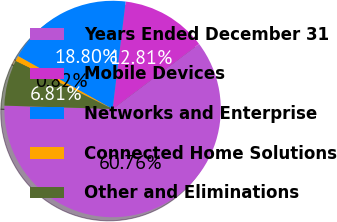Convert chart to OTSL. <chart><loc_0><loc_0><loc_500><loc_500><pie_chart><fcel>Years Ended December 31<fcel>Mobile Devices<fcel>Networks and Enterprise<fcel>Connected Home Solutions<fcel>Other and Eliminations<nl><fcel>60.76%<fcel>12.81%<fcel>18.8%<fcel>0.82%<fcel>6.81%<nl></chart> 